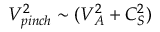Convert formula to latex. <formula><loc_0><loc_0><loc_500><loc_500>V _ { p i n c h } ^ { 2 } \sim ( V _ { A } ^ { 2 } + C _ { S } ^ { 2 } )</formula> 